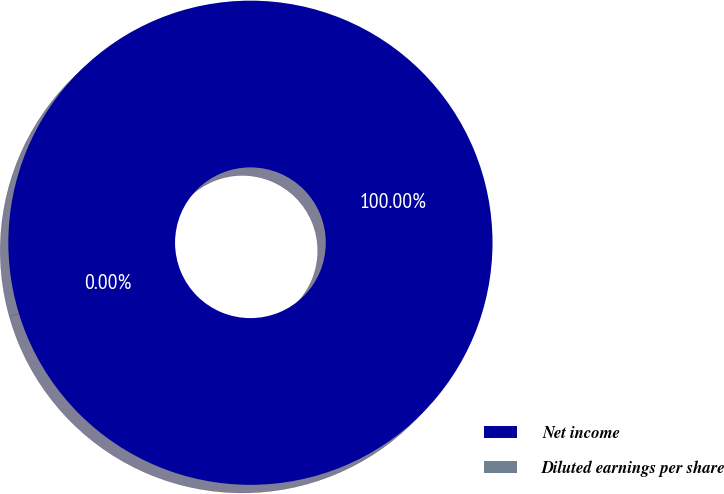<chart> <loc_0><loc_0><loc_500><loc_500><pie_chart><fcel>Net income<fcel>Diluted earnings per share<nl><fcel>100.0%<fcel>0.0%<nl></chart> 